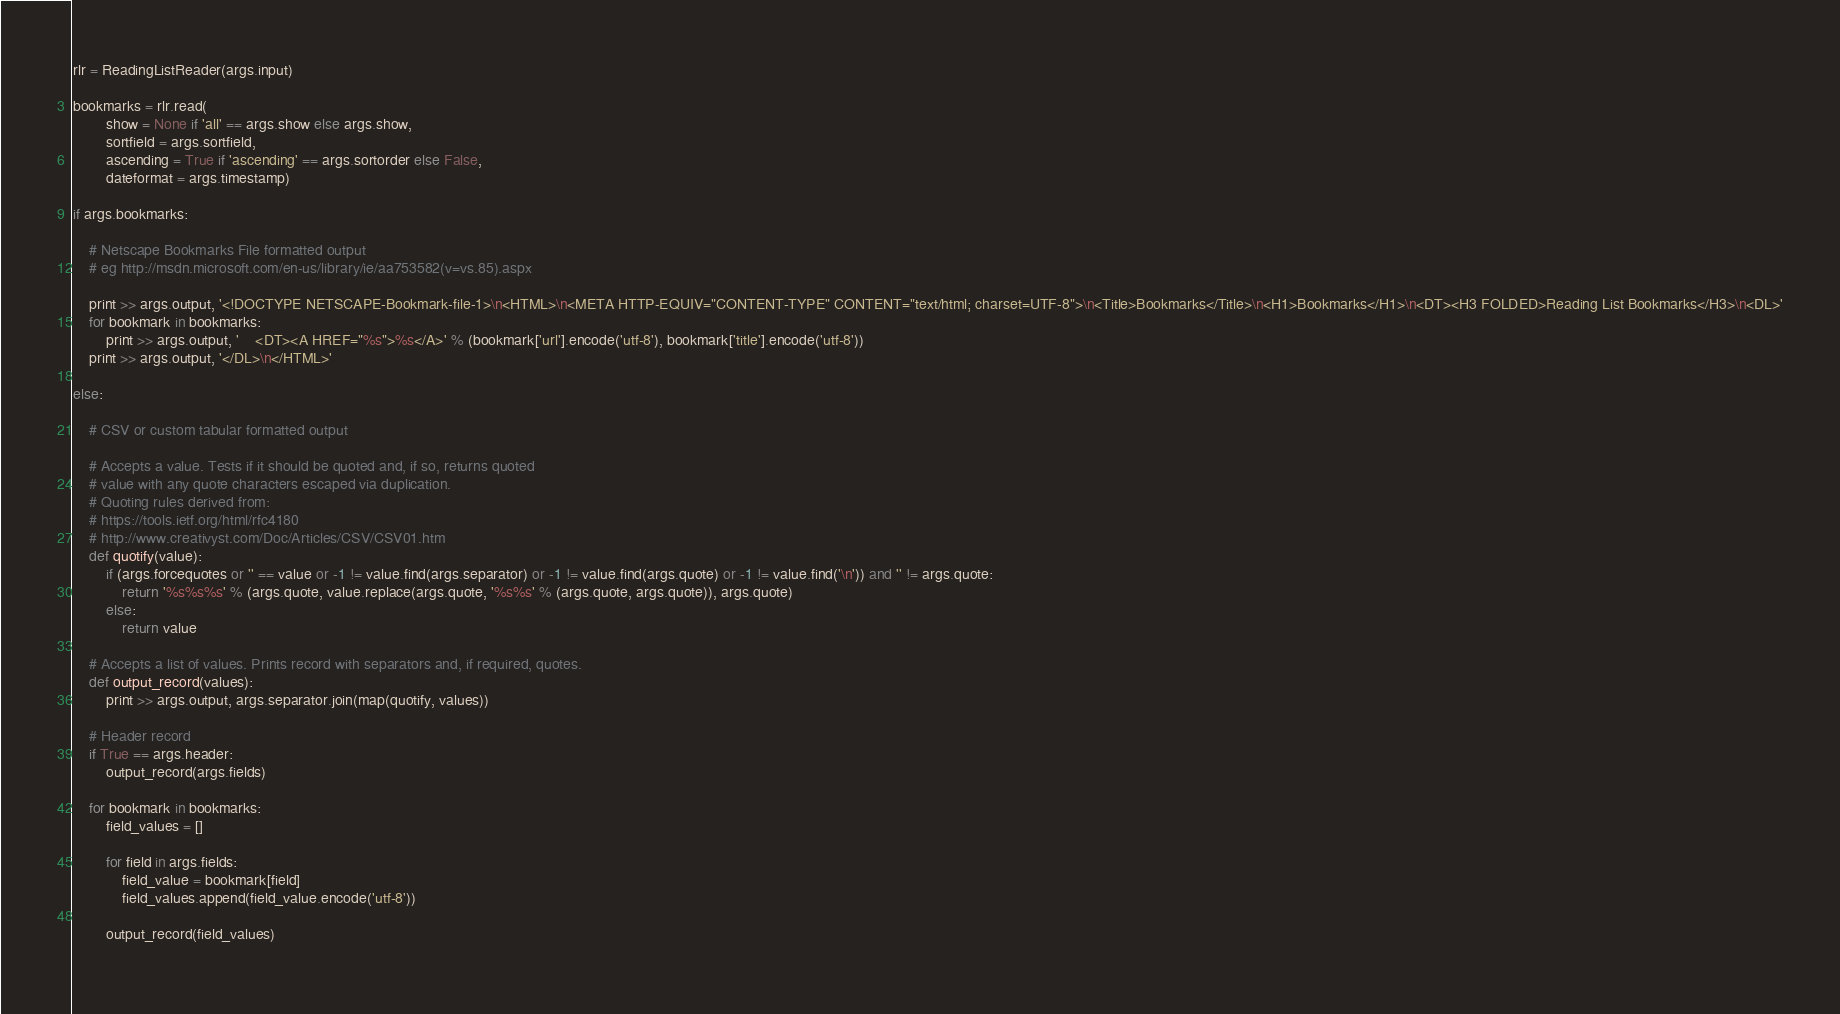Convert code to text. <code><loc_0><loc_0><loc_500><loc_500><_Python_>rlr = ReadingListReader(args.input)

bookmarks = rlr.read(
		show = None if 'all' == args.show else args.show,
		sortfield = args.sortfield,
		ascending = True if 'ascending' == args.sortorder else False,
		dateformat = args.timestamp)

if args.bookmarks:

	# Netscape Bookmarks File formatted output
	# eg http://msdn.microsoft.com/en-us/library/ie/aa753582(v=vs.85).aspx
	
	print >> args.output, '<!DOCTYPE NETSCAPE-Bookmark-file-1>\n<HTML>\n<META HTTP-EQUIV="CONTENT-TYPE" CONTENT="text/html; charset=UTF-8">\n<Title>Bookmarks</Title>\n<H1>Bookmarks</H1>\n<DT><H3 FOLDED>Reading List Bookmarks</H3>\n<DL>'
	for bookmark in bookmarks:
		print >> args.output, '	<DT><A HREF="%s">%s</A>' % (bookmark['url'].encode('utf-8'), bookmark['title'].encode('utf-8'))
	print >> args.output, '</DL>\n</HTML>'

else:
	
	# CSV or custom tabular formatted output
	
	# Accepts a value. Tests if it should be quoted and, if so, returns quoted
	# value with any quote characters escaped via duplication.
	# Quoting rules derived from:
	# https://tools.ietf.org/html/rfc4180
	# http://www.creativyst.com/Doc/Articles/CSV/CSV01.htm
	def quotify(value):
		if (args.forcequotes or '' == value or -1 != value.find(args.separator) or -1 != value.find(args.quote) or -1 != value.find('\n')) and '' != args.quote:
			return '%s%s%s' % (args.quote, value.replace(args.quote, '%s%s' % (args.quote, args.quote)), args.quote)
		else:
			return value
	
	# Accepts a list of values. Prints record with separators and, if required, quotes.
	def output_record(values):
		print >> args.output, args.separator.join(map(quotify, values))
	
	# Header record
	if True == args.header:
		output_record(args.fields)
	
	for bookmark in bookmarks:
		field_values = []
		
		for field in args.fields:
			field_value = bookmark[field]			
			field_values.append(field_value.encode('utf-8'))
		
		output_record(field_values)
	
</code> 